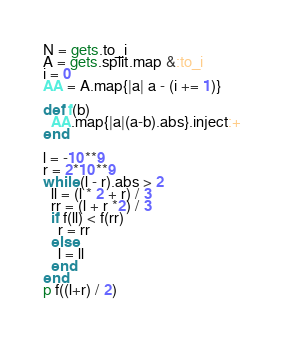Convert code to text. <code><loc_0><loc_0><loc_500><loc_500><_Ruby_>N = gets.to_i
A = gets.split.map &:to_i
i = 0
AA = A.map{|a| a - (i += 1)}

def f(b)
  AA.map{|a|(a-b).abs}.inject:+
end

l = -10**9
r = 2*10**9
while (l - r).abs > 2
  ll = (l * 2 + r) / 3
  rr = (l + r *2) / 3
  if f(ll) < f(rr)
    r = rr
  else
    l = ll
  end
end
p f((l+r) / 2)
</code> 